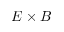Convert formula to latex. <formula><loc_0><loc_0><loc_500><loc_500>E \times B</formula> 